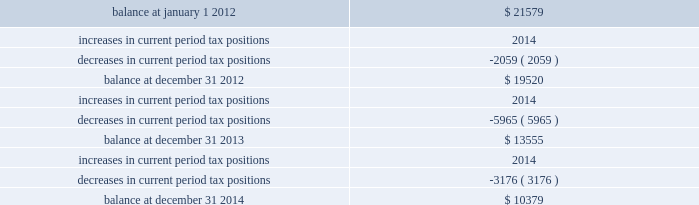Majority of the increased tax position is attributable to temporary differences .
The increase in 2014 current period tax positions related primarily to the company 2019s change in tax accounting method filed in 2008 for repair and maintenance costs on its utility plant .
The company does not anticipate material changes to its unrecognized tax benefits within the next year .
If the company sustains all of its positions at december 31 , 2014 and 2013 , an unrecognized tax benefit of $ 9444 and $ 7439 , respectively , excluding interest and penalties , would impact the company 2019s effective tax rate .
The table summarizes the changes in the company 2019s valuation allowance: .
Included in 2013 is a discrete tax benefit totaling $ 2979 associated with an entity re-organization within the company 2019s market-based operations segment that allowed for the utilization of state net operating loss carryforwards and the release of an associated valuation allowance .
Note 13 : employee benefits pension and other postretirement benefits the company maintains noncontributory defined benefit pension plans covering eligible employees of its regulated utility and shared services operations .
Benefits under the plans are based on the employee 2019s years of service and compensation .
The pension plans have been closed for all employees .
The pension plans were closed for most employees hired on or after january 1 , 2006 .
Union employees hired on or after january 1 , 2001 had their accrued benefit frozen and will be able to receive this benefit as a lump sum upon termination or retirement .
Union employees hired on or after january 1 , 2001 and non-union employees hired on or after january 1 , 2006 are provided with a 5.25% ( 5.25 % ) of base pay defined contribution plan .
The company does not participate in a multiemployer plan .
The company 2019s pension funding practice is to contribute at least the greater of the minimum amount required by the employee retirement income security act of 1974 or the normal cost .
Further , the company will consider additional contributions if needed to avoid 201cat risk 201d status and benefit restrictions under the pension protection act of 2006 .
The company may also consider increased contributions , based on other financial requirements and the plans 2019 funded position .
Pension plan assets are invested in a number of actively managed and commingled funds including equity and bond funds , fixed income securities , guaranteed interest contracts with insurance companies , real estate funds and real estate investment trusts ( 201creits 201d ) .
Pension expense in excess of the amount contributed to the pension plans is deferred by certain regulated subsidiaries pending future recovery in rates charged for utility services as contributions are made to the plans .
( see note 6 ) the company also has unfunded noncontributory supplemental non-qualified pension plans that provide additional retirement benefits to certain employees. .
In 2014 what was the ratio of the decrease in tax positions compared to the end balance? 
Rationale: the ratio of the decrease in 2014 as part of the end balance means divide the decease by the end balance
Computations: ((3176 * const_m1) / 10379)
Answer: -0.306. 